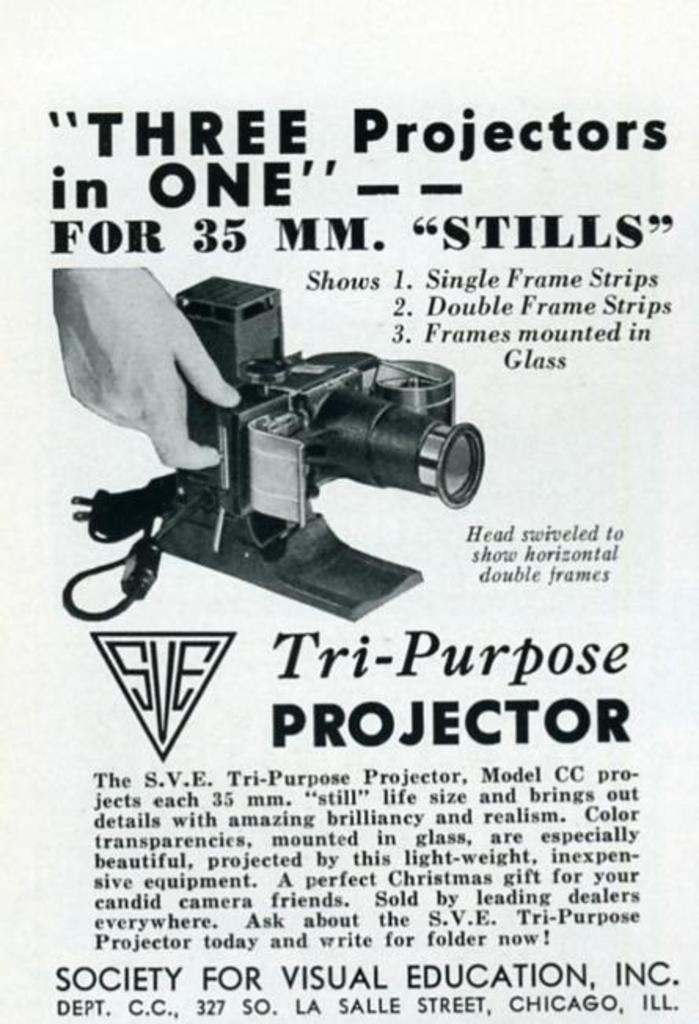Provide a one-sentence caption for the provided image. An article that is advertising three projectors in one. 